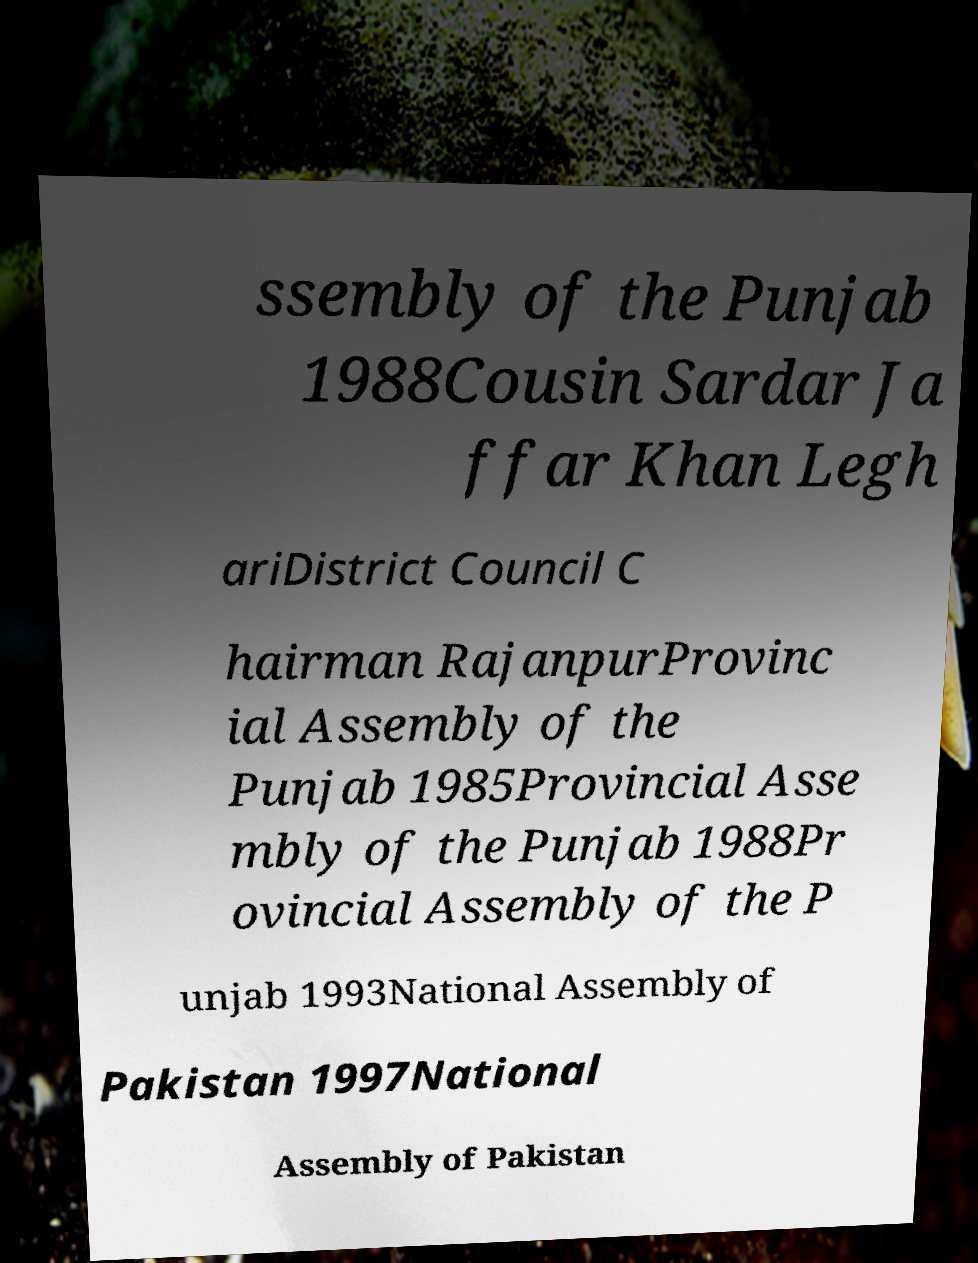For documentation purposes, I need the text within this image transcribed. Could you provide that? ssembly of the Punjab 1988Cousin Sardar Ja ffar Khan Legh ariDistrict Council C hairman RajanpurProvinc ial Assembly of the Punjab 1985Provincial Asse mbly of the Punjab 1988Pr ovincial Assembly of the P unjab 1993National Assembly of Pakistan 1997National Assembly of Pakistan 